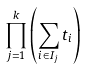<formula> <loc_0><loc_0><loc_500><loc_500>\prod _ { j = 1 } ^ { k } \left ( \sum _ { i \in I _ { j } } t _ { i } \right )</formula> 